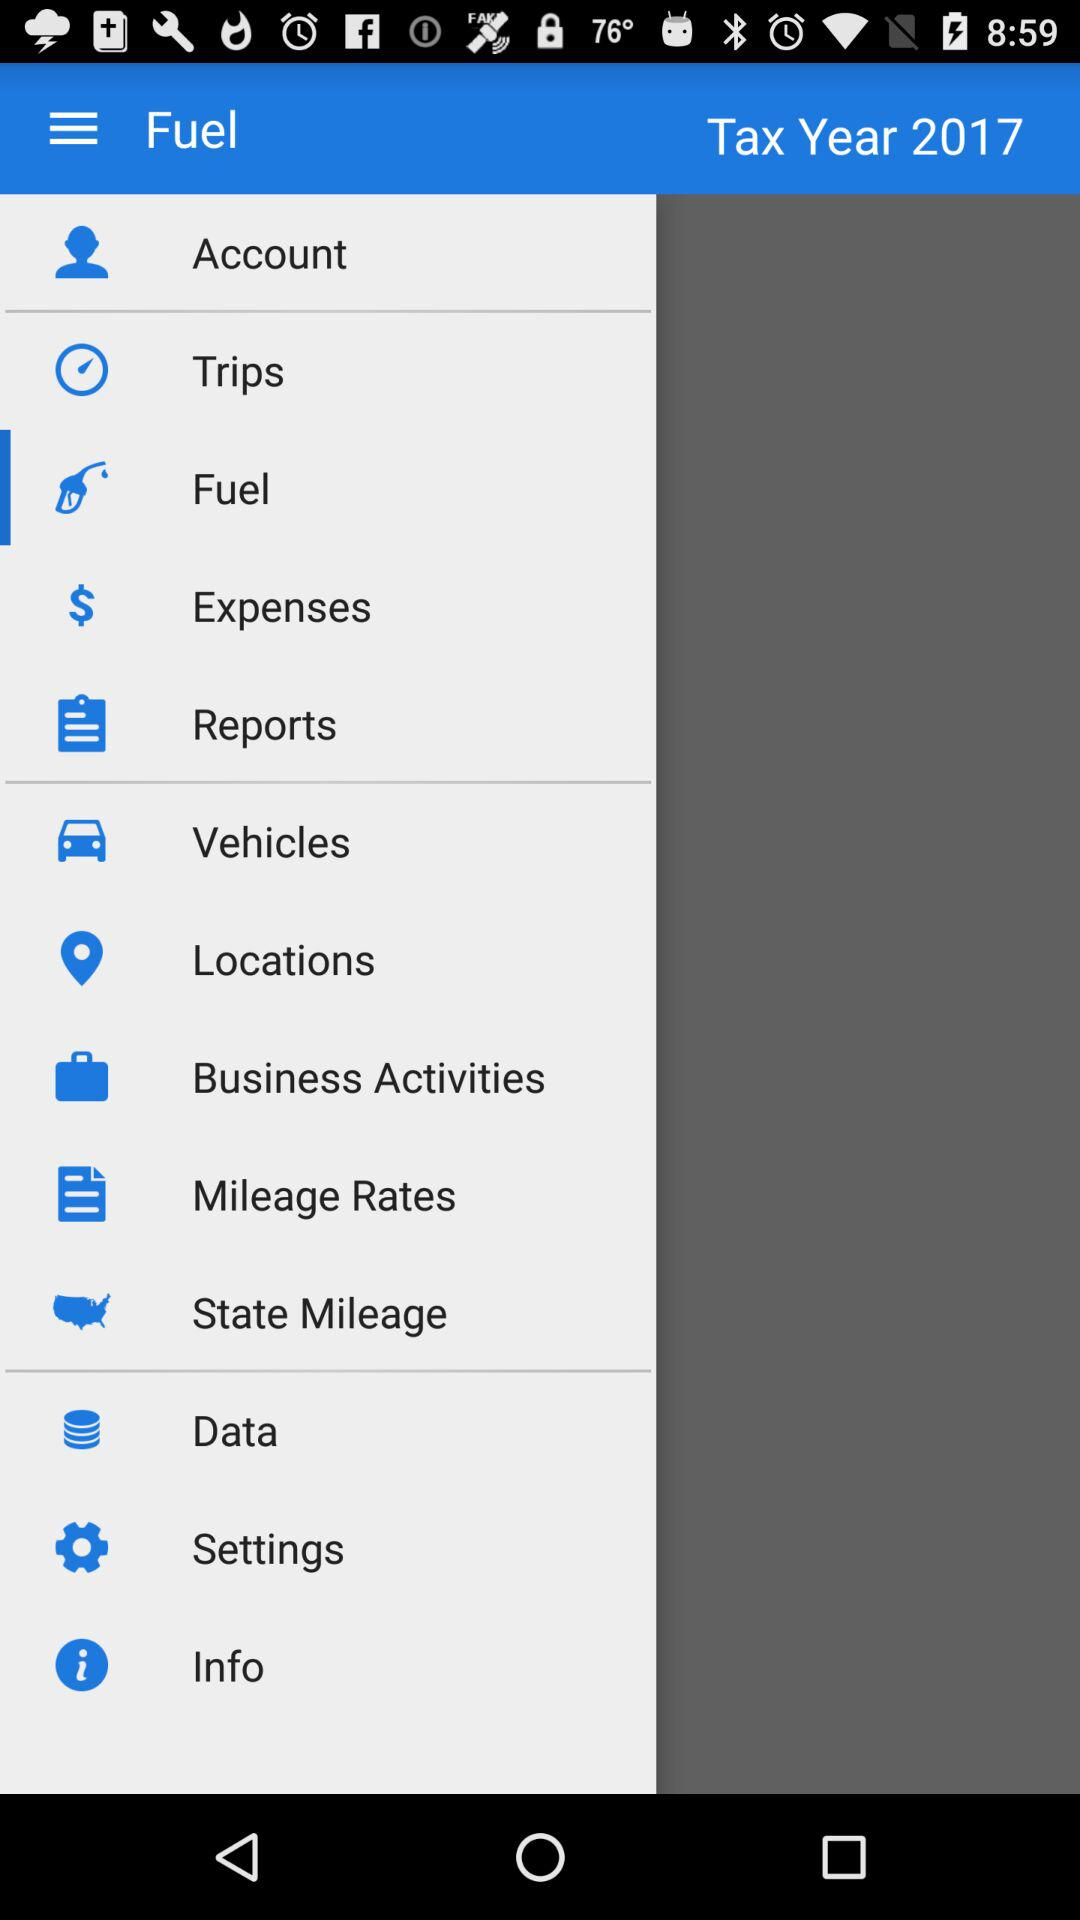What is the application name? The application name is "Fuel". 